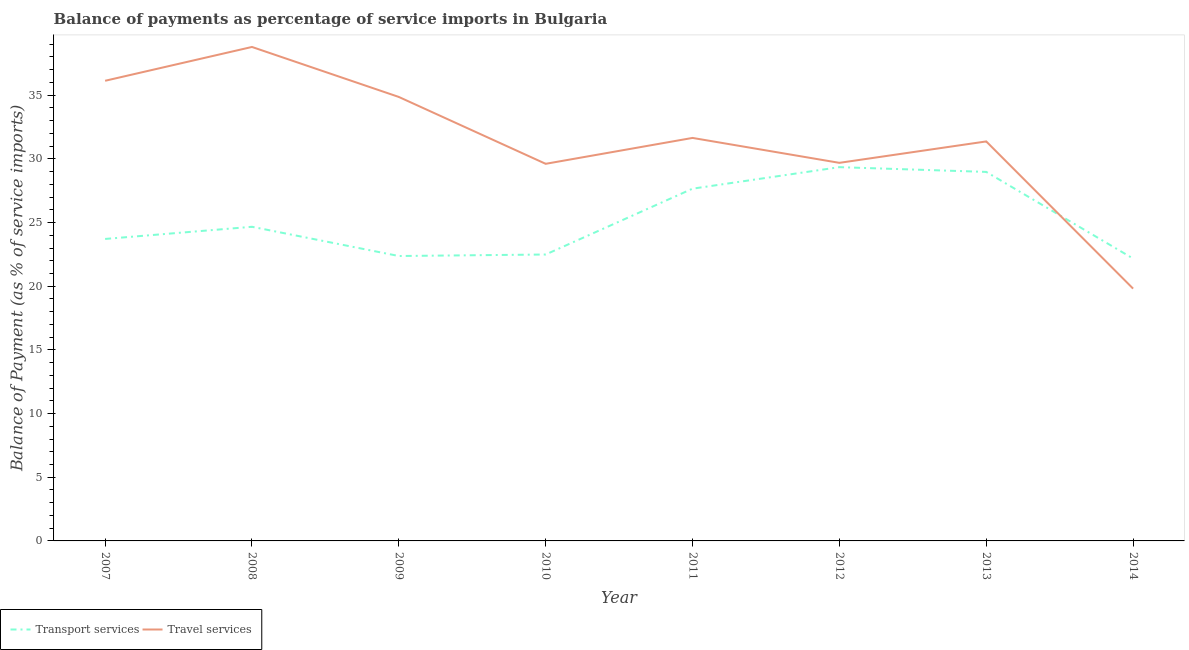How many different coloured lines are there?
Keep it short and to the point. 2. What is the balance of payments of travel services in 2014?
Offer a very short reply. 19.81. Across all years, what is the maximum balance of payments of transport services?
Provide a short and direct response. 29.35. Across all years, what is the minimum balance of payments of transport services?
Ensure brevity in your answer.  22.17. In which year was the balance of payments of transport services minimum?
Make the answer very short. 2014. What is the total balance of payments of travel services in the graph?
Provide a short and direct response. 251.91. What is the difference between the balance of payments of transport services in 2007 and that in 2014?
Your answer should be very brief. 1.54. What is the difference between the balance of payments of travel services in 2014 and the balance of payments of transport services in 2008?
Keep it short and to the point. -4.86. What is the average balance of payments of travel services per year?
Your answer should be very brief. 31.49. In the year 2012, what is the difference between the balance of payments of transport services and balance of payments of travel services?
Provide a succinct answer. -0.34. In how many years, is the balance of payments of travel services greater than 30 %?
Keep it short and to the point. 5. What is the ratio of the balance of payments of travel services in 2011 to that in 2013?
Offer a terse response. 1.01. What is the difference between the highest and the second highest balance of payments of travel services?
Keep it short and to the point. 2.66. What is the difference between the highest and the lowest balance of payments of transport services?
Make the answer very short. 7.18. Is the balance of payments of transport services strictly greater than the balance of payments of travel services over the years?
Ensure brevity in your answer.  No. Is the balance of payments of transport services strictly less than the balance of payments of travel services over the years?
Make the answer very short. No. How many years are there in the graph?
Keep it short and to the point. 8. Are the values on the major ticks of Y-axis written in scientific E-notation?
Make the answer very short. No. Does the graph contain any zero values?
Provide a succinct answer. No. Does the graph contain grids?
Offer a very short reply. No. How many legend labels are there?
Offer a terse response. 2. What is the title of the graph?
Provide a succinct answer. Balance of payments as percentage of service imports in Bulgaria. What is the label or title of the Y-axis?
Your answer should be compact. Balance of Payment (as % of service imports). What is the Balance of Payment (as % of service imports) of Transport services in 2007?
Provide a succinct answer. 23.71. What is the Balance of Payment (as % of service imports) in Travel services in 2007?
Ensure brevity in your answer.  36.13. What is the Balance of Payment (as % of service imports) in Transport services in 2008?
Ensure brevity in your answer.  24.67. What is the Balance of Payment (as % of service imports) of Travel services in 2008?
Your response must be concise. 38.79. What is the Balance of Payment (as % of service imports) of Transport services in 2009?
Give a very brief answer. 22.37. What is the Balance of Payment (as % of service imports) in Travel services in 2009?
Make the answer very short. 34.86. What is the Balance of Payment (as % of service imports) in Transport services in 2010?
Your answer should be compact. 22.49. What is the Balance of Payment (as % of service imports) of Travel services in 2010?
Your answer should be very brief. 29.61. What is the Balance of Payment (as % of service imports) in Transport services in 2011?
Offer a very short reply. 27.66. What is the Balance of Payment (as % of service imports) in Travel services in 2011?
Make the answer very short. 31.65. What is the Balance of Payment (as % of service imports) in Transport services in 2012?
Offer a very short reply. 29.35. What is the Balance of Payment (as % of service imports) in Travel services in 2012?
Your answer should be compact. 29.69. What is the Balance of Payment (as % of service imports) in Transport services in 2013?
Offer a terse response. 28.98. What is the Balance of Payment (as % of service imports) in Travel services in 2013?
Provide a short and direct response. 31.37. What is the Balance of Payment (as % of service imports) of Transport services in 2014?
Your answer should be very brief. 22.17. What is the Balance of Payment (as % of service imports) of Travel services in 2014?
Provide a succinct answer. 19.81. Across all years, what is the maximum Balance of Payment (as % of service imports) in Transport services?
Your answer should be compact. 29.35. Across all years, what is the maximum Balance of Payment (as % of service imports) in Travel services?
Keep it short and to the point. 38.79. Across all years, what is the minimum Balance of Payment (as % of service imports) of Transport services?
Keep it short and to the point. 22.17. Across all years, what is the minimum Balance of Payment (as % of service imports) of Travel services?
Your answer should be compact. 19.81. What is the total Balance of Payment (as % of service imports) of Transport services in the graph?
Give a very brief answer. 201.4. What is the total Balance of Payment (as % of service imports) in Travel services in the graph?
Give a very brief answer. 251.91. What is the difference between the Balance of Payment (as % of service imports) of Transport services in 2007 and that in 2008?
Offer a terse response. -0.96. What is the difference between the Balance of Payment (as % of service imports) of Travel services in 2007 and that in 2008?
Your response must be concise. -2.66. What is the difference between the Balance of Payment (as % of service imports) of Transport services in 2007 and that in 2009?
Give a very brief answer. 1.34. What is the difference between the Balance of Payment (as % of service imports) of Travel services in 2007 and that in 2009?
Keep it short and to the point. 1.27. What is the difference between the Balance of Payment (as % of service imports) in Transport services in 2007 and that in 2010?
Your answer should be very brief. 1.22. What is the difference between the Balance of Payment (as % of service imports) in Travel services in 2007 and that in 2010?
Your answer should be compact. 6.52. What is the difference between the Balance of Payment (as % of service imports) of Transport services in 2007 and that in 2011?
Ensure brevity in your answer.  -3.95. What is the difference between the Balance of Payment (as % of service imports) of Travel services in 2007 and that in 2011?
Offer a very short reply. 4.49. What is the difference between the Balance of Payment (as % of service imports) of Transport services in 2007 and that in 2012?
Provide a succinct answer. -5.64. What is the difference between the Balance of Payment (as % of service imports) in Travel services in 2007 and that in 2012?
Your answer should be very brief. 6.44. What is the difference between the Balance of Payment (as % of service imports) in Transport services in 2007 and that in 2013?
Provide a short and direct response. -5.26. What is the difference between the Balance of Payment (as % of service imports) in Travel services in 2007 and that in 2013?
Make the answer very short. 4.76. What is the difference between the Balance of Payment (as % of service imports) in Transport services in 2007 and that in 2014?
Provide a succinct answer. 1.54. What is the difference between the Balance of Payment (as % of service imports) in Travel services in 2007 and that in 2014?
Make the answer very short. 16.32. What is the difference between the Balance of Payment (as % of service imports) of Transport services in 2008 and that in 2009?
Offer a very short reply. 2.3. What is the difference between the Balance of Payment (as % of service imports) of Travel services in 2008 and that in 2009?
Offer a terse response. 3.93. What is the difference between the Balance of Payment (as % of service imports) in Transport services in 2008 and that in 2010?
Provide a short and direct response. 2.18. What is the difference between the Balance of Payment (as % of service imports) of Travel services in 2008 and that in 2010?
Your answer should be very brief. 9.18. What is the difference between the Balance of Payment (as % of service imports) of Transport services in 2008 and that in 2011?
Offer a very short reply. -2.99. What is the difference between the Balance of Payment (as % of service imports) of Travel services in 2008 and that in 2011?
Your answer should be compact. 7.14. What is the difference between the Balance of Payment (as % of service imports) in Transport services in 2008 and that in 2012?
Your answer should be compact. -4.68. What is the difference between the Balance of Payment (as % of service imports) in Travel services in 2008 and that in 2012?
Provide a short and direct response. 9.1. What is the difference between the Balance of Payment (as % of service imports) of Transport services in 2008 and that in 2013?
Offer a terse response. -4.31. What is the difference between the Balance of Payment (as % of service imports) of Travel services in 2008 and that in 2013?
Your response must be concise. 7.42. What is the difference between the Balance of Payment (as % of service imports) of Transport services in 2008 and that in 2014?
Your response must be concise. 2.49. What is the difference between the Balance of Payment (as % of service imports) in Travel services in 2008 and that in 2014?
Provide a succinct answer. 18.98. What is the difference between the Balance of Payment (as % of service imports) of Transport services in 2009 and that in 2010?
Your answer should be very brief. -0.12. What is the difference between the Balance of Payment (as % of service imports) of Travel services in 2009 and that in 2010?
Offer a terse response. 5.25. What is the difference between the Balance of Payment (as % of service imports) in Transport services in 2009 and that in 2011?
Keep it short and to the point. -5.29. What is the difference between the Balance of Payment (as % of service imports) of Travel services in 2009 and that in 2011?
Ensure brevity in your answer.  3.22. What is the difference between the Balance of Payment (as % of service imports) of Transport services in 2009 and that in 2012?
Keep it short and to the point. -6.98. What is the difference between the Balance of Payment (as % of service imports) in Travel services in 2009 and that in 2012?
Offer a terse response. 5.17. What is the difference between the Balance of Payment (as % of service imports) of Transport services in 2009 and that in 2013?
Your answer should be very brief. -6.6. What is the difference between the Balance of Payment (as % of service imports) of Travel services in 2009 and that in 2013?
Offer a terse response. 3.49. What is the difference between the Balance of Payment (as % of service imports) in Transport services in 2009 and that in 2014?
Provide a succinct answer. 0.2. What is the difference between the Balance of Payment (as % of service imports) in Travel services in 2009 and that in 2014?
Your response must be concise. 15.05. What is the difference between the Balance of Payment (as % of service imports) of Transport services in 2010 and that in 2011?
Offer a terse response. -5.17. What is the difference between the Balance of Payment (as % of service imports) of Travel services in 2010 and that in 2011?
Make the answer very short. -2.03. What is the difference between the Balance of Payment (as % of service imports) of Transport services in 2010 and that in 2012?
Keep it short and to the point. -6.86. What is the difference between the Balance of Payment (as % of service imports) of Travel services in 2010 and that in 2012?
Your answer should be very brief. -0.08. What is the difference between the Balance of Payment (as % of service imports) of Transport services in 2010 and that in 2013?
Make the answer very short. -6.49. What is the difference between the Balance of Payment (as % of service imports) in Travel services in 2010 and that in 2013?
Make the answer very short. -1.76. What is the difference between the Balance of Payment (as % of service imports) of Transport services in 2010 and that in 2014?
Give a very brief answer. 0.32. What is the difference between the Balance of Payment (as % of service imports) of Travel services in 2010 and that in 2014?
Make the answer very short. 9.8. What is the difference between the Balance of Payment (as % of service imports) of Transport services in 2011 and that in 2012?
Keep it short and to the point. -1.69. What is the difference between the Balance of Payment (as % of service imports) in Travel services in 2011 and that in 2012?
Make the answer very short. 1.96. What is the difference between the Balance of Payment (as % of service imports) of Transport services in 2011 and that in 2013?
Give a very brief answer. -1.32. What is the difference between the Balance of Payment (as % of service imports) in Travel services in 2011 and that in 2013?
Ensure brevity in your answer.  0.28. What is the difference between the Balance of Payment (as % of service imports) in Transport services in 2011 and that in 2014?
Your response must be concise. 5.49. What is the difference between the Balance of Payment (as % of service imports) of Travel services in 2011 and that in 2014?
Your answer should be very brief. 11.83. What is the difference between the Balance of Payment (as % of service imports) in Transport services in 2012 and that in 2013?
Your response must be concise. 0.37. What is the difference between the Balance of Payment (as % of service imports) in Travel services in 2012 and that in 2013?
Make the answer very short. -1.68. What is the difference between the Balance of Payment (as % of service imports) in Transport services in 2012 and that in 2014?
Your answer should be very brief. 7.18. What is the difference between the Balance of Payment (as % of service imports) in Travel services in 2012 and that in 2014?
Your response must be concise. 9.88. What is the difference between the Balance of Payment (as % of service imports) in Transport services in 2013 and that in 2014?
Offer a terse response. 6.8. What is the difference between the Balance of Payment (as % of service imports) in Travel services in 2013 and that in 2014?
Your response must be concise. 11.56. What is the difference between the Balance of Payment (as % of service imports) in Transport services in 2007 and the Balance of Payment (as % of service imports) in Travel services in 2008?
Your answer should be compact. -15.08. What is the difference between the Balance of Payment (as % of service imports) in Transport services in 2007 and the Balance of Payment (as % of service imports) in Travel services in 2009?
Provide a succinct answer. -11.15. What is the difference between the Balance of Payment (as % of service imports) in Transport services in 2007 and the Balance of Payment (as % of service imports) in Travel services in 2010?
Ensure brevity in your answer.  -5.9. What is the difference between the Balance of Payment (as % of service imports) of Transport services in 2007 and the Balance of Payment (as % of service imports) of Travel services in 2011?
Keep it short and to the point. -7.93. What is the difference between the Balance of Payment (as % of service imports) of Transport services in 2007 and the Balance of Payment (as % of service imports) of Travel services in 2012?
Offer a terse response. -5.98. What is the difference between the Balance of Payment (as % of service imports) in Transport services in 2007 and the Balance of Payment (as % of service imports) in Travel services in 2013?
Provide a short and direct response. -7.66. What is the difference between the Balance of Payment (as % of service imports) of Transport services in 2007 and the Balance of Payment (as % of service imports) of Travel services in 2014?
Your answer should be compact. 3.9. What is the difference between the Balance of Payment (as % of service imports) in Transport services in 2008 and the Balance of Payment (as % of service imports) in Travel services in 2009?
Offer a terse response. -10.19. What is the difference between the Balance of Payment (as % of service imports) of Transport services in 2008 and the Balance of Payment (as % of service imports) of Travel services in 2010?
Keep it short and to the point. -4.94. What is the difference between the Balance of Payment (as % of service imports) in Transport services in 2008 and the Balance of Payment (as % of service imports) in Travel services in 2011?
Ensure brevity in your answer.  -6.98. What is the difference between the Balance of Payment (as % of service imports) in Transport services in 2008 and the Balance of Payment (as % of service imports) in Travel services in 2012?
Give a very brief answer. -5.02. What is the difference between the Balance of Payment (as % of service imports) in Transport services in 2008 and the Balance of Payment (as % of service imports) in Travel services in 2013?
Your answer should be very brief. -6.7. What is the difference between the Balance of Payment (as % of service imports) of Transport services in 2008 and the Balance of Payment (as % of service imports) of Travel services in 2014?
Your answer should be very brief. 4.86. What is the difference between the Balance of Payment (as % of service imports) of Transport services in 2009 and the Balance of Payment (as % of service imports) of Travel services in 2010?
Keep it short and to the point. -7.24. What is the difference between the Balance of Payment (as % of service imports) of Transport services in 2009 and the Balance of Payment (as % of service imports) of Travel services in 2011?
Offer a very short reply. -9.27. What is the difference between the Balance of Payment (as % of service imports) of Transport services in 2009 and the Balance of Payment (as % of service imports) of Travel services in 2012?
Provide a short and direct response. -7.32. What is the difference between the Balance of Payment (as % of service imports) of Transport services in 2009 and the Balance of Payment (as % of service imports) of Travel services in 2013?
Ensure brevity in your answer.  -9. What is the difference between the Balance of Payment (as % of service imports) of Transport services in 2009 and the Balance of Payment (as % of service imports) of Travel services in 2014?
Provide a short and direct response. 2.56. What is the difference between the Balance of Payment (as % of service imports) in Transport services in 2010 and the Balance of Payment (as % of service imports) in Travel services in 2011?
Provide a short and direct response. -9.15. What is the difference between the Balance of Payment (as % of service imports) in Transport services in 2010 and the Balance of Payment (as % of service imports) in Travel services in 2012?
Offer a terse response. -7.2. What is the difference between the Balance of Payment (as % of service imports) of Transport services in 2010 and the Balance of Payment (as % of service imports) of Travel services in 2013?
Your answer should be very brief. -8.88. What is the difference between the Balance of Payment (as % of service imports) of Transport services in 2010 and the Balance of Payment (as % of service imports) of Travel services in 2014?
Your answer should be compact. 2.68. What is the difference between the Balance of Payment (as % of service imports) of Transport services in 2011 and the Balance of Payment (as % of service imports) of Travel services in 2012?
Give a very brief answer. -2.03. What is the difference between the Balance of Payment (as % of service imports) in Transport services in 2011 and the Balance of Payment (as % of service imports) in Travel services in 2013?
Make the answer very short. -3.71. What is the difference between the Balance of Payment (as % of service imports) of Transport services in 2011 and the Balance of Payment (as % of service imports) of Travel services in 2014?
Provide a short and direct response. 7.85. What is the difference between the Balance of Payment (as % of service imports) of Transport services in 2012 and the Balance of Payment (as % of service imports) of Travel services in 2013?
Provide a succinct answer. -2.02. What is the difference between the Balance of Payment (as % of service imports) of Transport services in 2012 and the Balance of Payment (as % of service imports) of Travel services in 2014?
Provide a succinct answer. 9.54. What is the difference between the Balance of Payment (as % of service imports) of Transport services in 2013 and the Balance of Payment (as % of service imports) of Travel services in 2014?
Ensure brevity in your answer.  9.16. What is the average Balance of Payment (as % of service imports) of Transport services per year?
Offer a terse response. 25.18. What is the average Balance of Payment (as % of service imports) in Travel services per year?
Your answer should be very brief. 31.49. In the year 2007, what is the difference between the Balance of Payment (as % of service imports) of Transport services and Balance of Payment (as % of service imports) of Travel services?
Your answer should be very brief. -12.42. In the year 2008, what is the difference between the Balance of Payment (as % of service imports) in Transport services and Balance of Payment (as % of service imports) in Travel services?
Provide a short and direct response. -14.12. In the year 2009, what is the difference between the Balance of Payment (as % of service imports) in Transport services and Balance of Payment (as % of service imports) in Travel services?
Keep it short and to the point. -12.49. In the year 2010, what is the difference between the Balance of Payment (as % of service imports) of Transport services and Balance of Payment (as % of service imports) of Travel services?
Provide a succinct answer. -7.12. In the year 2011, what is the difference between the Balance of Payment (as % of service imports) of Transport services and Balance of Payment (as % of service imports) of Travel services?
Provide a short and direct response. -3.99. In the year 2012, what is the difference between the Balance of Payment (as % of service imports) in Transport services and Balance of Payment (as % of service imports) in Travel services?
Your answer should be compact. -0.34. In the year 2013, what is the difference between the Balance of Payment (as % of service imports) in Transport services and Balance of Payment (as % of service imports) in Travel services?
Provide a short and direct response. -2.39. In the year 2014, what is the difference between the Balance of Payment (as % of service imports) in Transport services and Balance of Payment (as % of service imports) in Travel services?
Ensure brevity in your answer.  2.36. What is the ratio of the Balance of Payment (as % of service imports) in Transport services in 2007 to that in 2008?
Offer a very short reply. 0.96. What is the ratio of the Balance of Payment (as % of service imports) of Travel services in 2007 to that in 2008?
Your answer should be very brief. 0.93. What is the ratio of the Balance of Payment (as % of service imports) in Transport services in 2007 to that in 2009?
Keep it short and to the point. 1.06. What is the ratio of the Balance of Payment (as % of service imports) of Travel services in 2007 to that in 2009?
Your answer should be compact. 1.04. What is the ratio of the Balance of Payment (as % of service imports) of Transport services in 2007 to that in 2010?
Provide a short and direct response. 1.05. What is the ratio of the Balance of Payment (as % of service imports) in Travel services in 2007 to that in 2010?
Give a very brief answer. 1.22. What is the ratio of the Balance of Payment (as % of service imports) of Transport services in 2007 to that in 2011?
Your response must be concise. 0.86. What is the ratio of the Balance of Payment (as % of service imports) of Travel services in 2007 to that in 2011?
Provide a succinct answer. 1.14. What is the ratio of the Balance of Payment (as % of service imports) in Transport services in 2007 to that in 2012?
Your response must be concise. 0.81. What is the ratio of the Balance of Payment (as % of service imports) in Travel services in 2007 to that in 2012?
Offer a terse response. 1.22. What is the ratio of the Balance of Payment (as % of service imports) of Transport services in 2007 to that in 2013?
Provide a succinct answer. 0.82. What is the ratio of the Balance of Payment (as % of service imports) of Travel services in 2007 to that in 2013?
Your answer should be very brief. 1.15. What is the ratio of the Balance of Payment (as % of service imports) of Transport services in 2007 to that in 2014?
Your answer should be very brief. 1.07. What is the ratio of the Balance of Payment (as % of service imports) in Travel services in 2007 to that in 2014?
Make the answer very short. 1.82. What is the ratio of the Balance of Payment (as % of service imports) in Transport services in 2008 to that in 2009?
Ensure brevity in your answer.  1.1. What is the ratio of the Balance of Payment (as % of service imports) in Travel services in 2008 to that in 2009?
Ensure brevity in your answer.  1.11. What is the ratio of the Balance of Payment (as % of service imports) of Transport services in 2008 to that in 2010?
Your answer should be very brief. 1.1. What is the ratio of the Balance of Payment (as % of service imports) in Travel services in 2008 to that in 2010?
Provide a succinct answer. 1.31. What is the ratio of the Balance of Payment (as % of service imports) in Transport services in 2008 to that in 2011?
Your response must be concise. 0.89. What is the ratio of the Balance of Payment (as % of service imports) of Travel services in 2008 to that in 2011?
Your answer should be very brief. 1.23. What is the ratio of the Balance of Payment (as % of service imports) of Transport services in 2008 to that in 2012?
Offer a very short reply. 0.84. What is the ratio of the Balance of Payment (as % of service imports) in Travel services in 2008 to that in 2012?
Provide a succinct answer. 1.31. What is the ratio of the Balance of Payment (as % of service imports) of Transport services in 2008 to that in 2013?
Offer a very short reply. 0.85. What is the ratio of the Balance of Payment (as % of service imports) of Travel services in 2008 to that in 2013?
Make the answer very short. 1.24. What is the ratio of the Balance of Payment (as % of service imports) in Transport services in 2008 to that in 2014?
Give a very brief answer. 1.11. What is the ratio of the Balance of Payment (as % of service imports) of Travel services in 2008 to that in 2014?
Offer a very short reply. 1.96. What is the ratio of the Balance of Payment (as % of service imports) of Transport services in 2009 to that in 2010?
Your answer should be compact. 0.99. What is the ratio of the Balance of Payment (as % of service imports) in Travel services in 2009 to that in 2010?
Your response must be concise. 1.18. What is the ratio of the Balance of Payment (as % of service imports) in Transport services in 2009 to that in 2011?
Ensure brevity in your answer.  0.81. What is the ratio of the Balance of Payment (as % of service imports) in Travel services in 2009 to that in 2011?
Keep it short and to the point. 1.1. What is the ratio of the Balance of Payment (as % of service imports) in Transport services in 2009 to that in 2012?
Offer a terse response. 0.76. What is the ratio of the Balance of Payment (as % of service imports) in Travel services in 2009 to that in 2012?
Offer a terse response. 1.17. What is the ratio of the Balance of Payment (as % of service imports) in Transport services in 2009 to that in 2013?
Provide a short and direct response. 0.77. What is the ratio of the Balance of Payment (as % of service imports) of Travel services in 2009 to that in 2013?
Give a very brief answer. 1.11. What is the ratio of the Balance of Payment (as % of service imports) of Travel services in 2009 to that in 2014?
Ensure brevity in your answer.  1.76. What is the ratio of the Balance of Payment (as % of service imports) in Transport services in 2010 to that in 2011?
Offer a terse response. 0.81. What is the ratio of the Balance of Payment (as % of service imports) of Travel services in 2010 to that in 2011?
Your response must be concise. 0.94. What is the ratio of the Balance of Payment (as % of service imports) in Transport services in 2010 to that in 2012?
Offer a terse response. 0.77. What is the ratio of the Balance of Payment (as % of service imports) of Transport services in 2010 to that in 2013?
Keep it short and to the point. 0.78. What is the ratio of the Balance of Payment (as % of service imports) of Travel services in 2010 to that in 2013?
Keep it short and to the point. 0.94. What is the ratio of the Balance of Payment (as % of service imports) in Transport services in 2010 to that in 2014?
Offer a terse response. 1.01. What is the ratio of the Balance of Payment (as % of service imports) in Travel services in 2010 to that in 2014?
Provide a short and direct response. 1.49. What is the ratio of the Balance of Payment (as % of service imports) in Transport services in 2011 to that in 2012?
Keep it short and to the point. 0.94. What is the ratio of the Balance of Payment (as % of service imports) of Travel services in 2011 to that in 2012?
Your answer should be compact. 1.07. What is the ratio of the Balance of Payment (as % of service imports) in Transport services in 2011 to that in 2013?
Offer a very short reply. 0.95. What is the ratio of the Balance of Payment (as % of service imports) of Travel services in 2011 to that in 2013?
Make the answer very short. 1.01. What is the ratio of the Balance of Payment (as % of service imports) of Transport services in 2011 to that in 2014?
Give a very brief answer. 1.25. What is the ratio of the Balance of Payment (as % of service imports) in Travel services in 2011 to that in 2014?
Give a very brief answer. 1.6. What is the ratio of the Balance of Payment (as % of service imports) of Transport services in 2012 to that in 2013?
Make the answer very short. 1.01. What is the ratio of the Balance of Payment (as % of service imports) in Travel services in 2012 to that in 2013?
Give a very brief answer. 0.95. What is the ratio of the Balance of Payment (as % of service imports) in Transport services in 2012 to that in 2014?
Make the answer very short. 1.32. What is the ratio of the Balance of Payment (as % of service imports) in Travel services in 2012 to that in 2014?
Provide a succinct answer. 1.5. What is the ratio of the Balance of Payment (as % of service imports) in Transport services in 2013 to that in 2014?
Provide a short and direct response. 1.31. What is the ratio of the Balance of Payment (as % of service imports) of Travel services in 2013 to that in 2014?
Your answer should be very brief. 1.58. What is the difference between the highest and the second highest Balance of Payment (as % of service imports) in Transport services?
Give a very brief answer. 0.37. What is the difference between the highest and the second highest Balance of Payment (as % of service imports) in Travel services?
Provide a succinct answer. 2.66. What is the difference between the highest and the lowest Balance of Payment (as % of service imports) of Transport services?
Your response must be concise. 7.18. What is the difference between the highest and the lowest Balance of Payment (as % of service imports) in Travel services?
Provide a succinct answer. 18.98. 